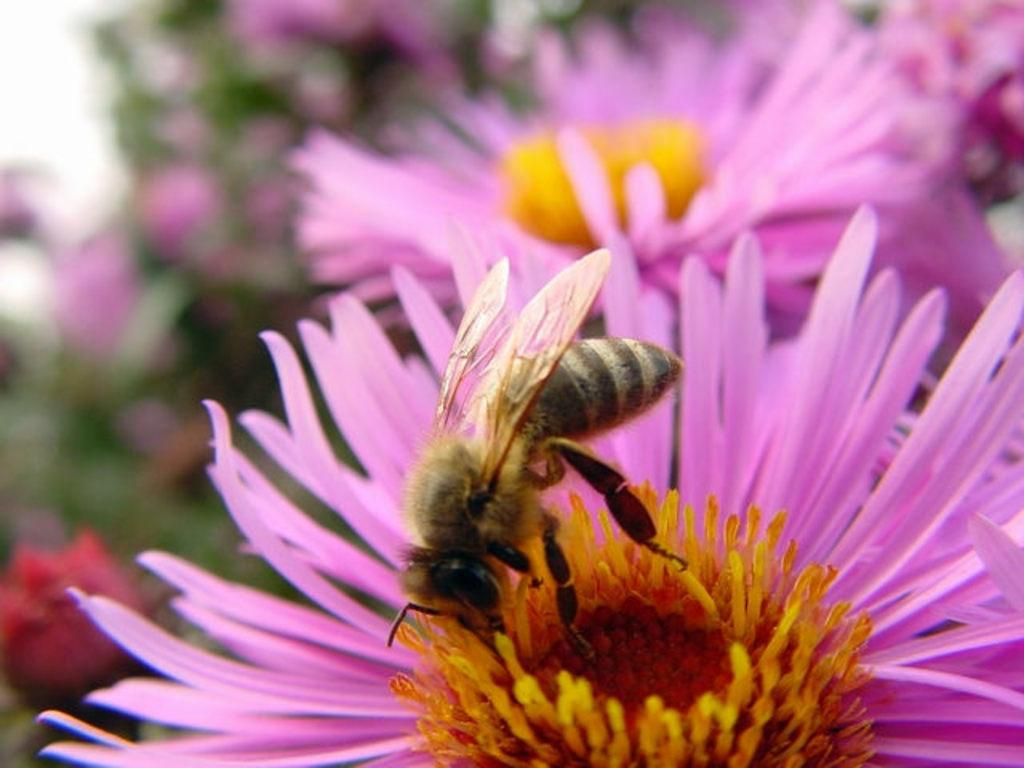What is the main subject in the center of the image? There are flowers in the center of the image. Can you describe any specific details about the flowers? A honey bee is present on a flower. What part of the image is blurry? The left side of the image is blurry. What is the name of the drink that the honey bee is holding in the image? There is no drink present in the image, and the honey bee is not holding anything. 